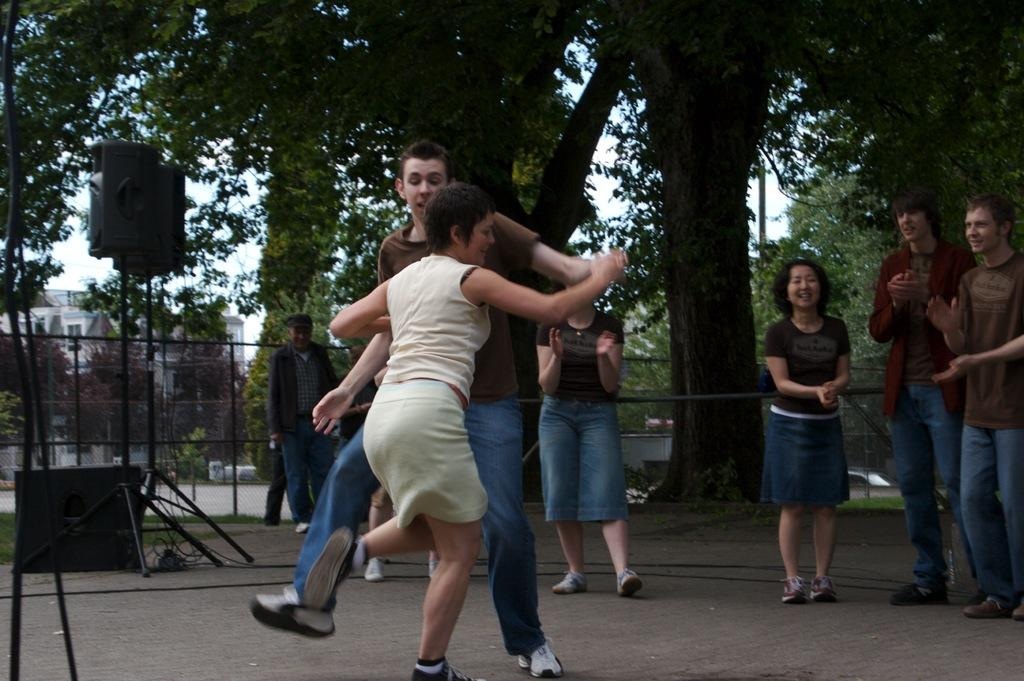What are the two people in the image doing? The two people in the image are dancing. What are the other people in the image doing? There are people standing in the image. What can be seen near the people in the image? There are speakers visible in the image. What is visible in the background of the image? There are trees, buildings, and fencing in the background of the image. What type of grip does the person in the image have on the request? There is no person holding a request in the image, and therefore no grip can be observed. 